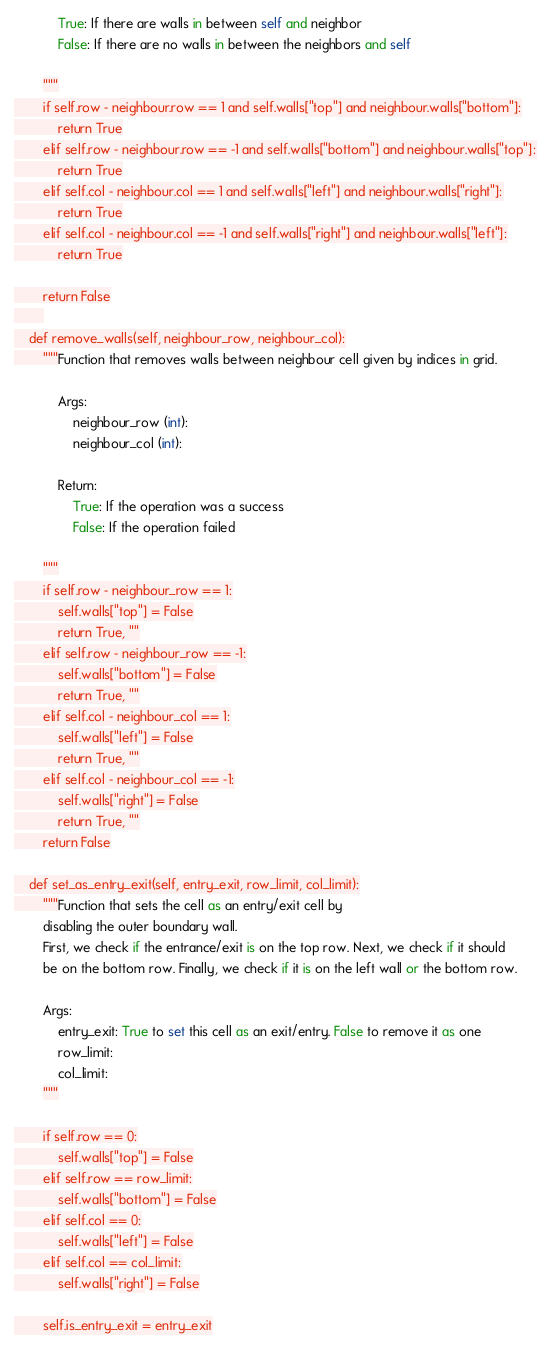Convert code to text. <code><loc_0><loc_0><loc_500><loc_500><_Python_>            True: If there are walls in between self and neighbor
            False: If there are no walls in between the neighbors and self

        """
        if self.row - neighbour.row == 1 and self.walls["top"] and neighbour.walls["bottom"]:
            return True
        elif self.row - neighbour.row == -1 and self.walls["bottom"] and neighbour.walls["top"]:
            return True
        elif self.col - neighbour.col == 1 and self.walls["left"] and neighbour.walls["right"]:
            return True
        elif self.col - neighbour.col == -1 and self.walls["right"] and neighbour.walls["left"]:
            return True

        return False
        
    def remove_walls(self, neighbour_row, neighbour_col):
        """Function that removes walls between neighbour cell given by indices in grid.

            Args:
                neighbour_row (int):
                neighbour_col (int):

            Return:
                True: If the operation was a success
                False: If the operation failed

        """
        if self.row - neighbour_row == 1:
            self.walls["top"] = False
            return True, ""
        elif self.row - neighbour_row == -1:
            self.walls["bottom"] = False
            return True, ""
        elif self.col - neighbour_col == 1:
            self.walls["left"] = False
            return True, ""
        elif self.col - neighbour_col == -1:
            self.walls["right"] = False
            return True, ""
        return False

    def set_as_entry_exit(self, entry_exit, row_limit, col_limit):
        """Function that sets the cell as an entry/exit cell by
        disabling the outer boundary wall.
        First, we check if the entrance/exit is on the top row. Next, we check if it should
        be on the bottom row. Finally, we check if it is on the left wall or the bottom row.

        Args:
            entry_exit: True to set this cell as an exit/entry. False to remove it as one
            row_limit:
            col_limit:
        """

        if self.row == 0:
            self.walls["top"] = False
        elif self.row == row_limit:
            self.walls["bottom"] = False
        elif self.col == 0:
            self.walls["left"] = False
        elif self.col == col_limit:
            self.walls["right"] = False

        self.is_entry_exit = entry_exit
</code> 